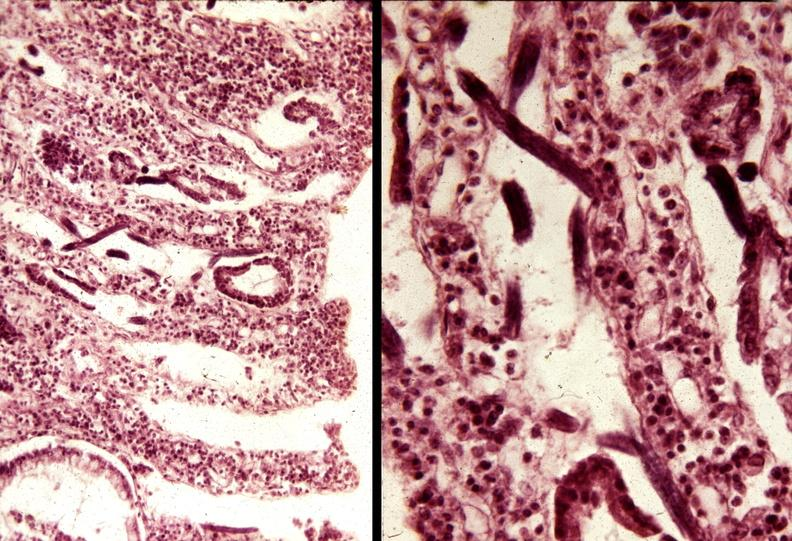where is this from?
Answer the question using a single word or phrase. Gastrointestinal system 